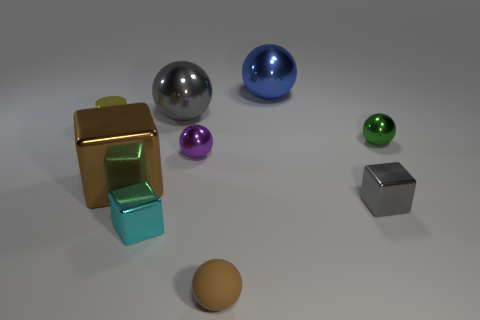Subtract all red spheres. Subtract all red cylinders. How many spheres are left? 5 Subtract all cylinders. How many objects are left? 8 Add 6 cyan things. How many cyan things exist? 7 Subtract 0 blue cylinders. How many objects are left? 9 Subtract all gray balls. Subtract all cubes. How many objects are left? 5 Add 4 tiny metallic objects. How many tiny metallic objects are left? 9 